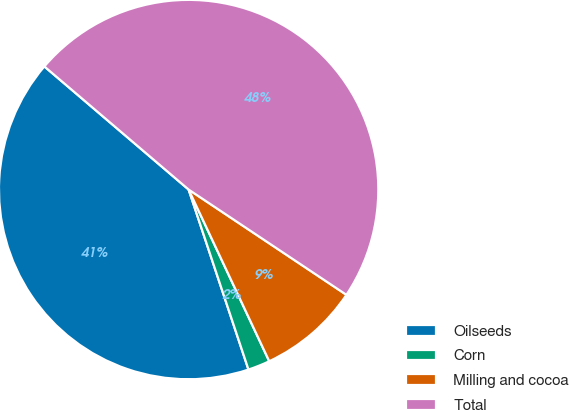Convert chart. <chart><loc_0><loc_0><loc_500><loc_500><pie_chart><fcel>Oilseeds<fcel>Corn<fcel>Milling and cocoa<fcel>Total<nl><fcel>41.35%<fcel>1.88%<fcel>8.65%<fcel>48.12%<nl></chart> 